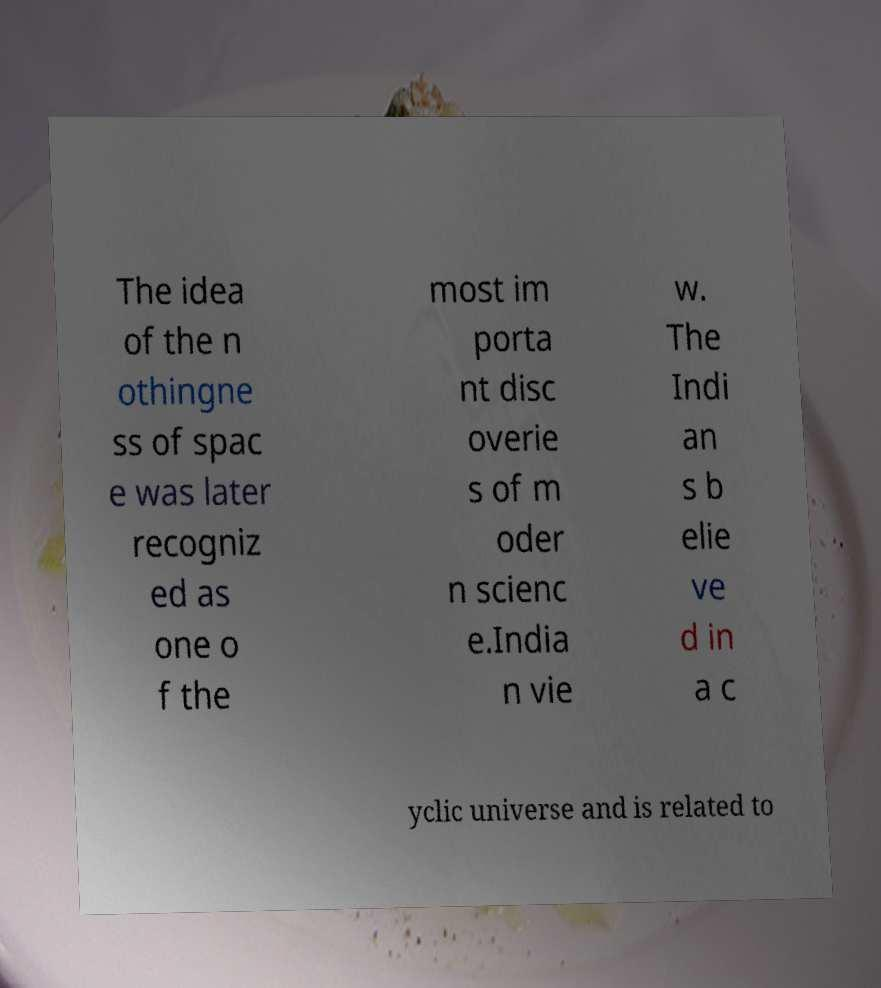Please read and relay the text visible in this image. What does it say? The idea of the n othingne ss of spac e was later recogniz ed as one o f the most im porta nt disc overie s of m oder n scienc e.India n vie w. The Indi an s b elie ve d in a c yclic universe and is related to 